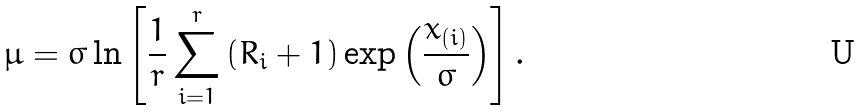Convert formula to latex. <formula><loc_0><loc_0><loc_500><loc_500>\mu = \sigma \ln \left [ \frac { 1 } { r } \sum _ { i = 1 } ^ { r } \left ( R _ { i } + 1 \right ) \exp \left ( \frac { x _ { ( i ) } } { \sigma } \right ) \right ] .</formula> 